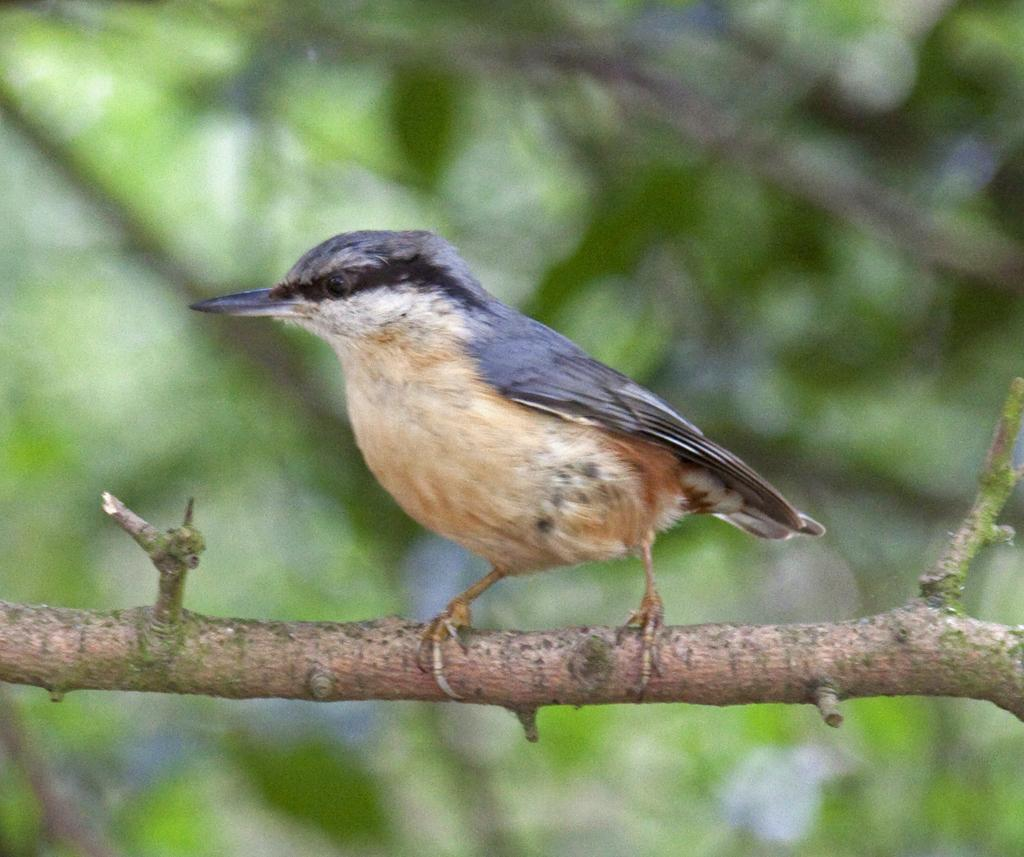What type of animal can be seen in the image? There is a bird in the image. Where is the bird located? The bird is standing on a branch of a tree. Can you describe the background of the image? The background of the image is blurry. What is the value of the station in the image? There is no station present in the image, so it is not possible to determine its value. 